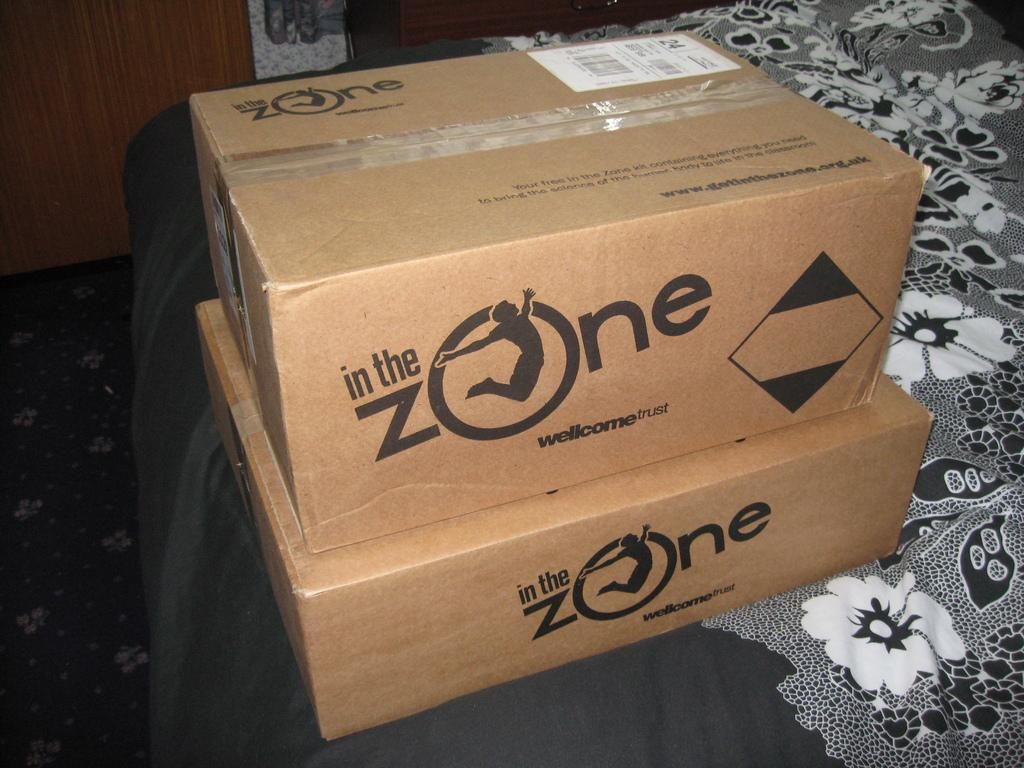<image>
Summarize the visual content of the image. In the Zone boxes sit stacked on top of one another on the table. 